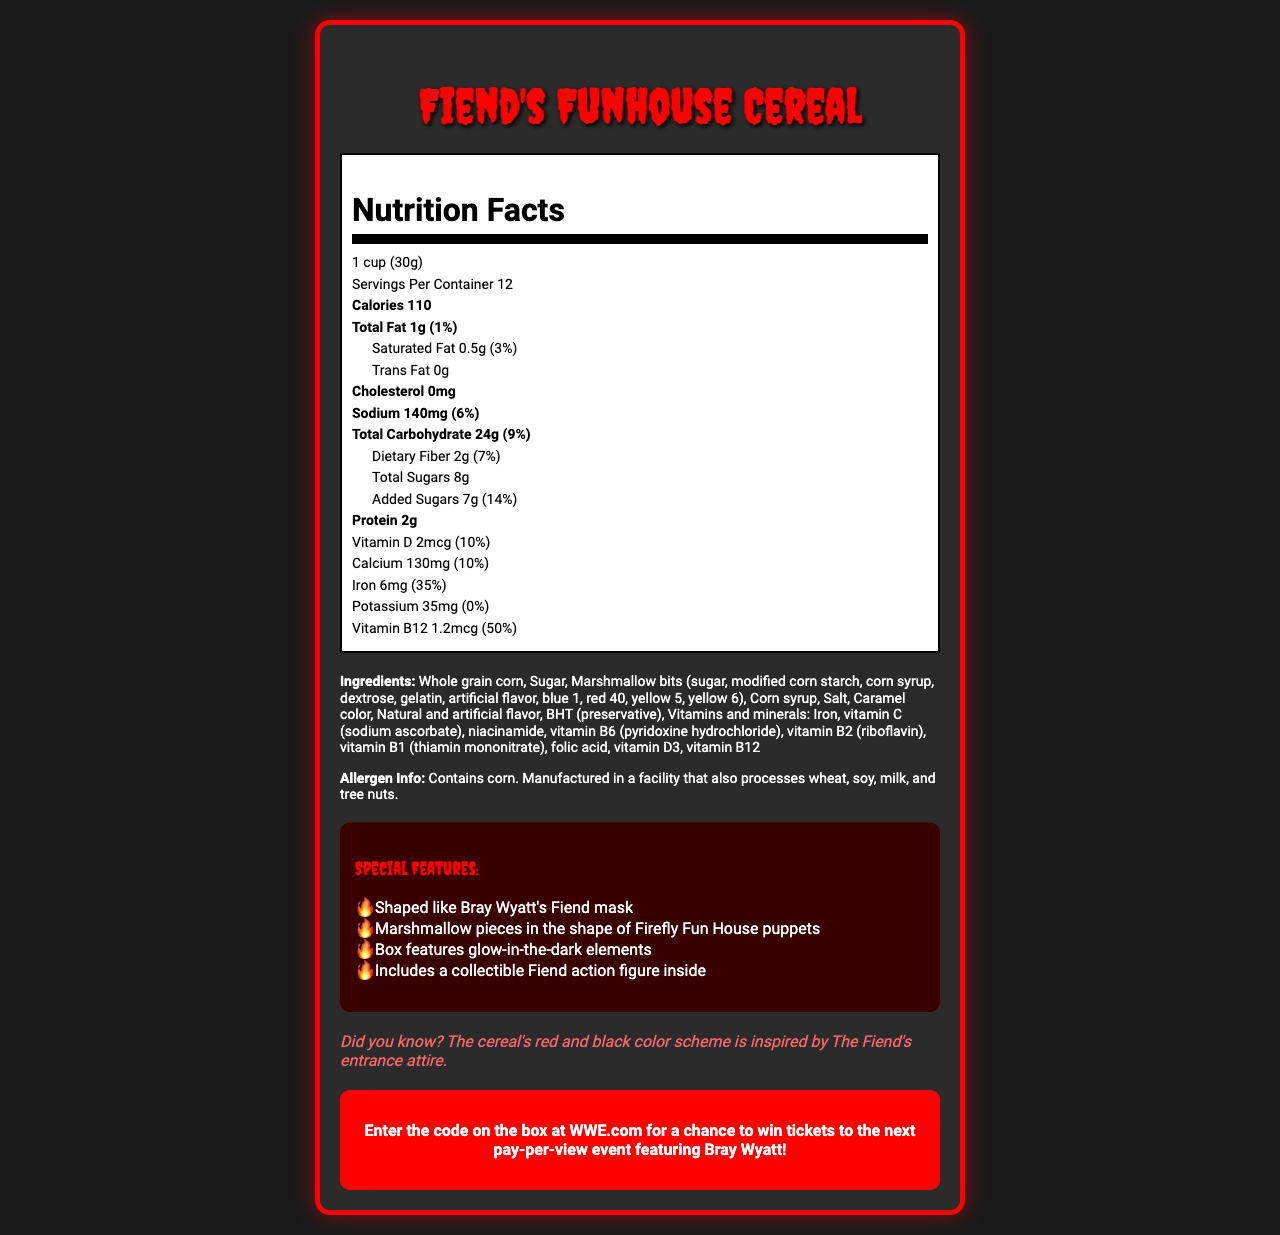what is the serving size? The serving size is stated at the beginning of the nutrition facts section.
Answer: 1 cup (30g) how many calories are in one serving? The calorie count is shown right after the serving size and servings per container, bolded as "Calories 110".
Answer: 110 what is the total amount of fat per serving? The total fat amount is listed right under the calorie count, indicated as "Total Fat 1g (1%)".
Answer: 1g how much iron does one serving provide in terms of daily value percentage? Iron is listed toward the bottom of the nutrition label, showing "Iron 6mg (35%)".
Answer: 35% what are the main ingredients of Fiend's Funhouse Cereal? The ingredients list is provided right below the nutrition facts label.
Answer: Whole grain corn, sugar, marshmallow bits, corn syrup, salt, caramel color, natural and artificial flavor, BHT (preservative), vitamins and minerals how many servings are there per container? This information is given right after the serving size, mentioned as "Servings Per Container: 12".
Answer: 12 does the Fiend's Funhouse Cereal contain any cholesterol? The label states cholesterol as "0mg", indicating there is no cholesterol in the cereal.
Answer: No how much added sugar is there per serving? Under the carbohydrates section, it's stated "Added Sugars 7g (14%)".
Answer: 7g true or false: The Fiend's Funhouse Cereal contains gluten. The allergen information specifies that the cereal contains corn and is manufactured in a facility that processes wheat, soy, milk, and tree nuts, but does not mention gluten explicitly.
Answer: False how is sodium content represented on the label? A. 50mg B. 100mg C. 140mg According to the label, the sodium content is indicated as "140mg".
Answer: C which special feature is NOT mentioned about the Fiend's Funhouse Cereal? A. Shaped like Bray Wyatt's Fiend mask B. Includes a collectible Fiend action figure C. Contains organic ingredients D. Box features glow-in-the-dark elements The features listed do not include anything about the cereal containing organic ingredients.
Answer: C can you win Bray Wyatt’s merchandise by purchasing Fiend’s Funhouse Cereal? The promotional offer only mentions a chance to win tickets to the next pay-per-view event, not specific merchandise.
Answer: Not enough information summarize the main idea of this document. The document details the nutritional content, ingredients, and fun aspects of the cereal, along with a promotional incentive for wrestling fans.
Answer: Fiend's Funhouse Cereal is a wrestling-themed breakfast cereal featuring Bray Wyatt's Fiend character. It has a nutritional breakdown, specific ingredients, and special features like marshmallow shapes related to Bray Wyatt's personas. It also includes a promotional offer for WWE fans. 